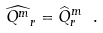Convert formula to latex. <formula><loc_0><loc_0><loc_500><loc_500>\widehat { Q ^ { m } } _ { r } = \widehat { Q } _ { r } ^ { m } \ .</formula> 